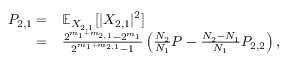<formula> <loc_0><loc_0><loc_500><loc_500>\begin{array} { r l } { P _ { 2 , 1 } = } & { \mathbb { E } _ { X _ { 2 , 1 } } [ | X _ { 2 , 1 } | ^ { 2 } ] } \\ { = } & { \frac { 2 ^ { m _ { 1 } + m _ { 2 , 1 } } - 2 ^ { m _ { 1 } } } { 2 ^ { m _ { 1 } + m _ { 2 , 1 } } - 1 } \left ( \frac { N _ { 2 } } { N _ { 1 } } P - \frac { N _ { 2 } - N _ { 1 } } { N _ { 1 } } P _ { 2 , 2 } \right ) , } \end{array}</formula> 